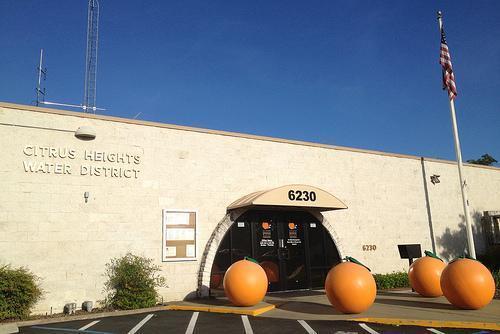How many oranges are seen?
Give a very brief answer. 4. 